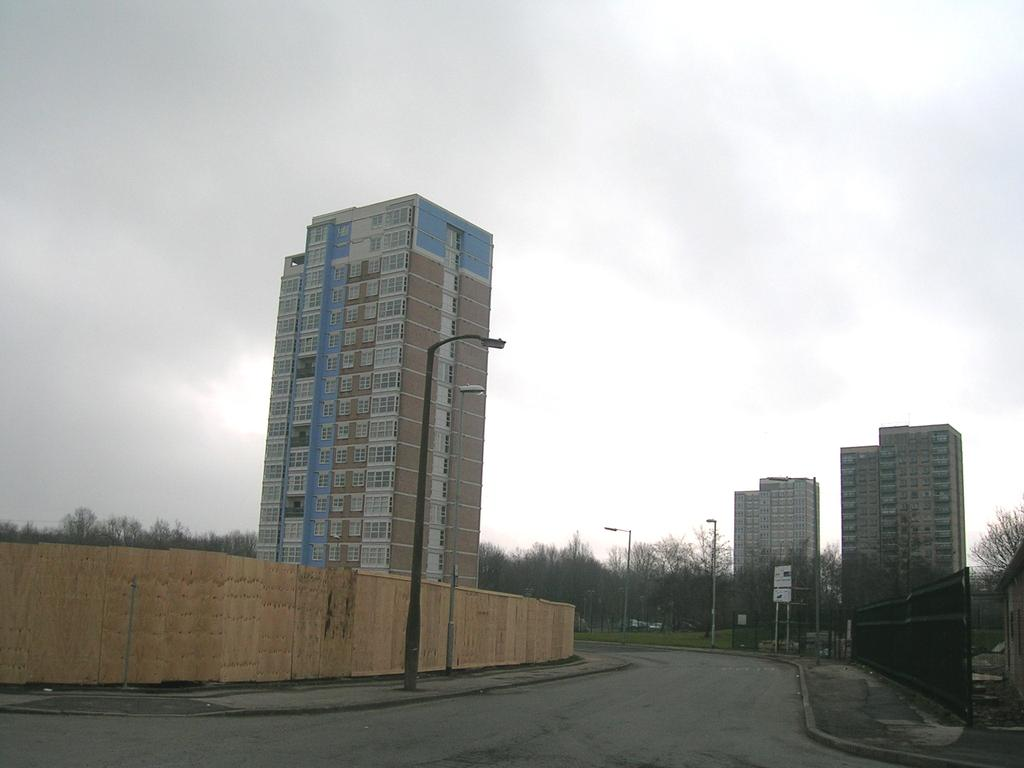What structures can be seen in the image? There are poles, lights, a road, buildings, and trees in the image. What type of environment is depicted in the image? The image shows an urban environment with buildings, roads, and lights. What can be seen in the background of the image? The sky is visible in the background of the image. What color are the trousers worn by the kitty playing with the balls in the image? There is no kitty or balls present in the image, and therefore no trousers or related colors can be observed. 